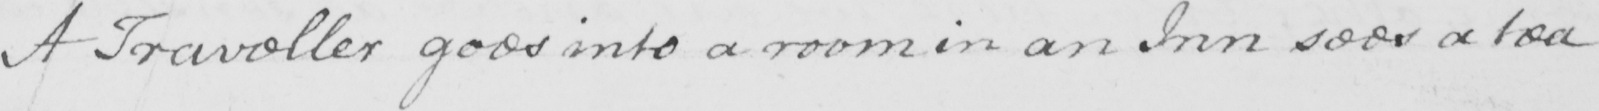What does this handwritten line say? A Traveller goes into a room in an Inn sees a tea 